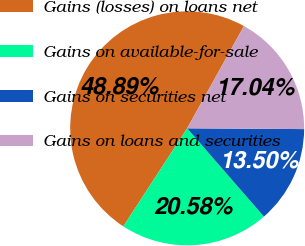Convert chart. <chart><loc_0><loc_0><loc_500><loc_500><pie_chart><fcel>Gains (losses) on loans net<fcel>Gains on available-for-sale<fcel>Gains on securities net<fcel>Gains on loans and securities<nl><fcel>48.89%<fcel>20.58%<fcel>13.5%<fcel>17.04%<nl></chart> 